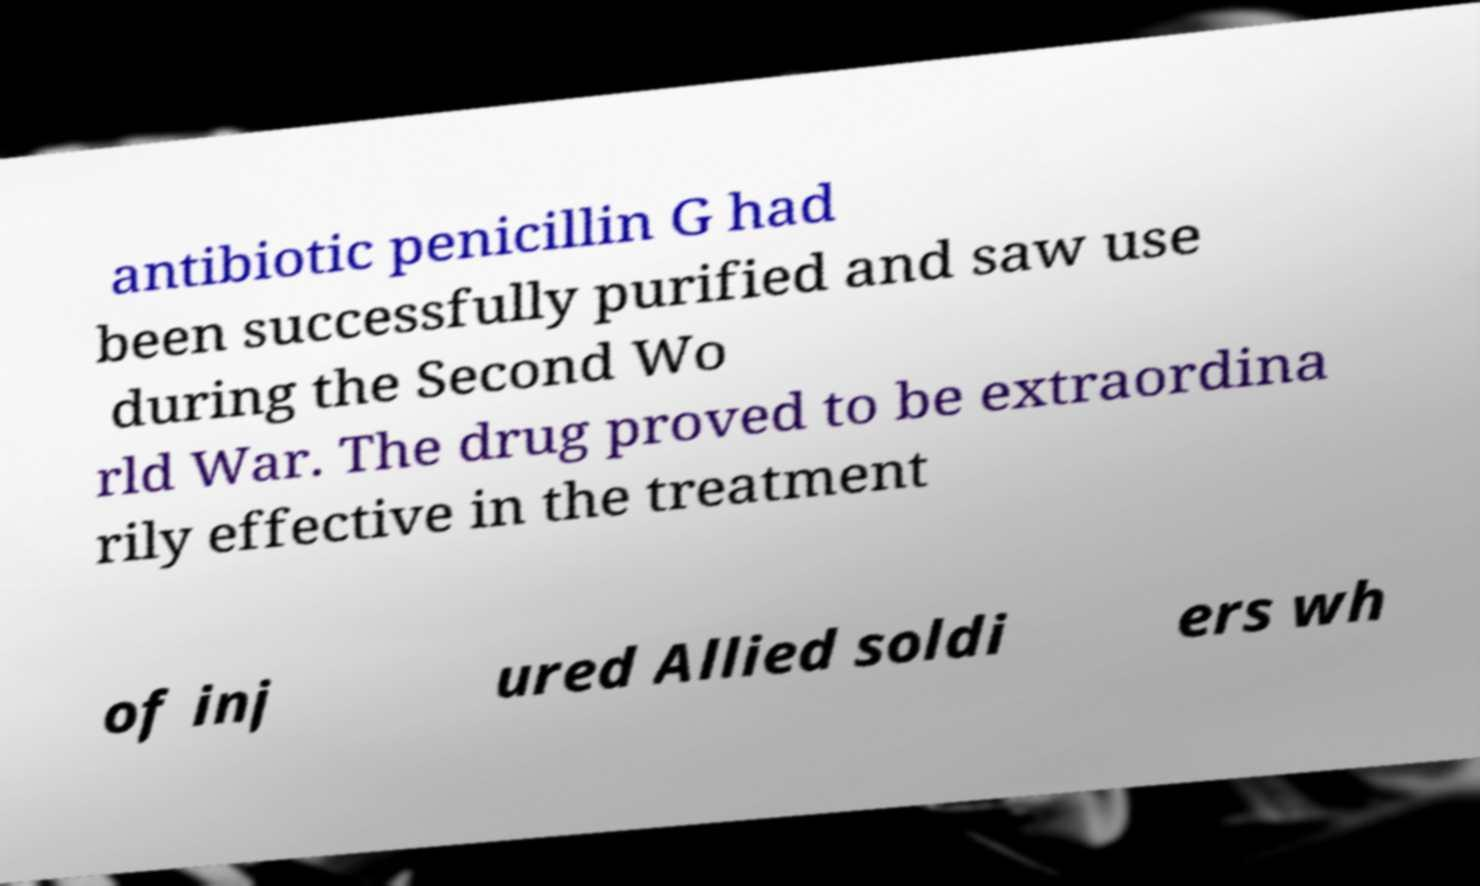For documentation purposes, I need the text within this image transcribed. Could you provide that? antibiotic penicillin G had been successfully purified and saw use during the Second Wo rld War. The drug proved to be extraordina rily effective in the treatment of inj ured Allied soldi ers wh 